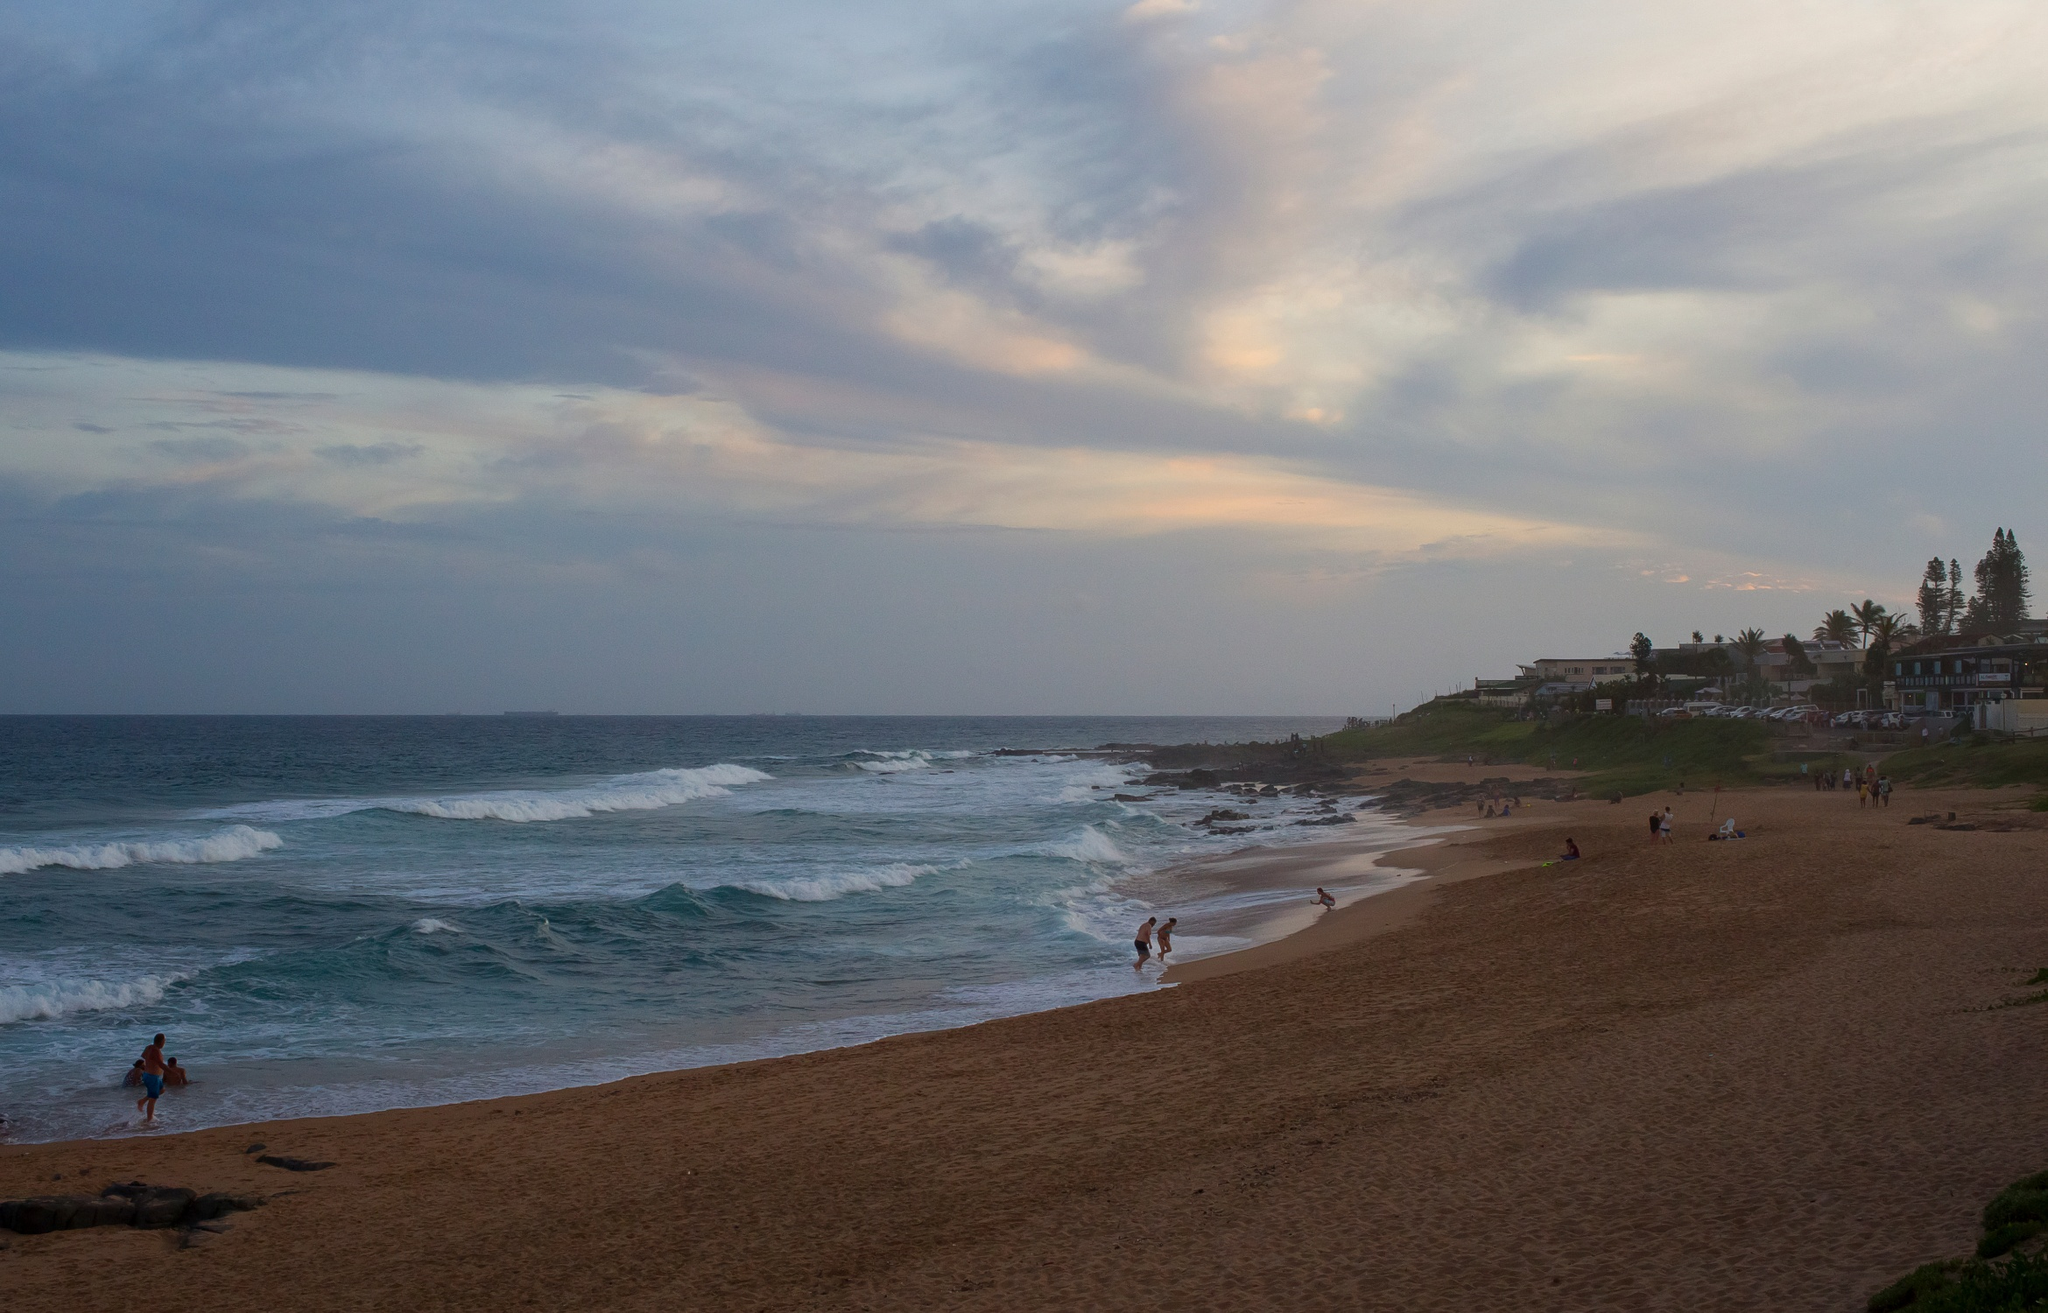What are the key elements in this picture? The image showcases a beautiful beach scene at sunset. The sky is adorned with fading shades of blue and orange as the sun sets in the horizon. The beach, covered in soft sands, features a few people enjoying different activities such as walking along the shore, playing near the water, or simply relaxing. The ocean, with its blue waters, displays gentle waves that meet the shore rhythmically. In the background, there are houses and trees perched on a cliff, offering a picturesque view of the beach below. The vantage point of this image appears to be from the beach itself, looking out towards the horizon where the sun meets the ocean, contributing to a serene and peaceful ambiance. 